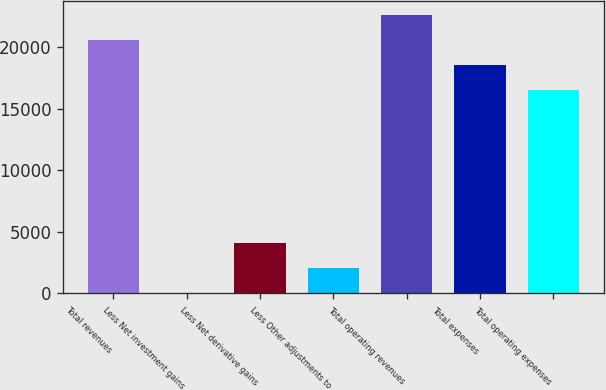<chart> <loc_0><loc_0><loc_500><loc_500><bar_chart><fcel>Total revenues<fcel>Less Net investment gains<fcel>Less Net derivative gains<fcel>Less Other adjustments to<fcel>Total operating revenues<fcel>Total expenses<fcel>Total operating expenses<nl><fcel>20575.2<fcel>70<fcel>4127.2<fcel>2098.6<fcel>22603.8<fcel>18546.6<fcel>16518<nl></chart> 